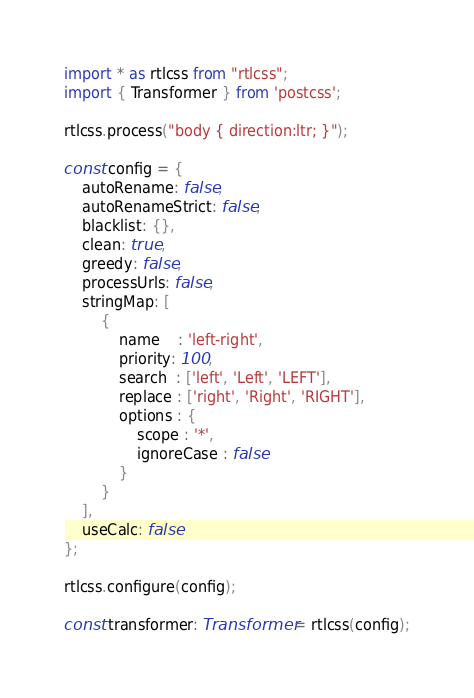Convert code to text. <code><loc_0><loc_0><loc_500><loc_500><_TypeScript_>import * as rtlcss from "rtlcss";
import { Transformer } from 'postcss';

rtlcss.process("body { direction:ltr; }");

const config = {
    autoRename: false,
    autoRenameStrict: false,
    blacklist: {},
    clean: true,
    greedy: false,
    processUrls: false,
    stringMap: [
        {
            name    : 'left-right',
            priority: 100,
            search  : ['left', 'Left', 'LEFT'],
            replace : ['right', 'Right', 'RIGHT'],
            options : {
                scope : '*',
                ignoreCase : false
            }
        }
    ],
    useCalc: false
};

rtlcss.configure(config);

const transformer: Transformer = rtlcss(config);
</code> 